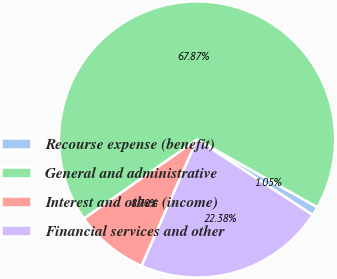Convert chart. <chart><loc_0><loc_0><loc_500><loc_500><pie_chart><fcel>Recourse expense (benefit)<fcel>General and administrative<fcel>Interest and other (income)<fcel>Financial services and other<nl><fcel>1.05%<fcel>67.87%<fcel>8.7%<fcel>22.38%<nl></chart> 